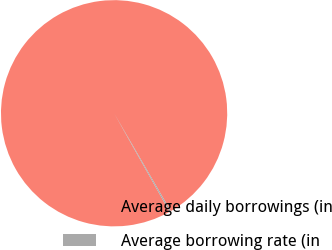Convert chart. <chart><loc_0><loc_0><loc_500><loc_500><pie_chart><fcel>Average daily borrowings (in<fcel>Average borrowing rate (in<nl><fcel>99.8%<fcel>0.2%<nl></chart> 